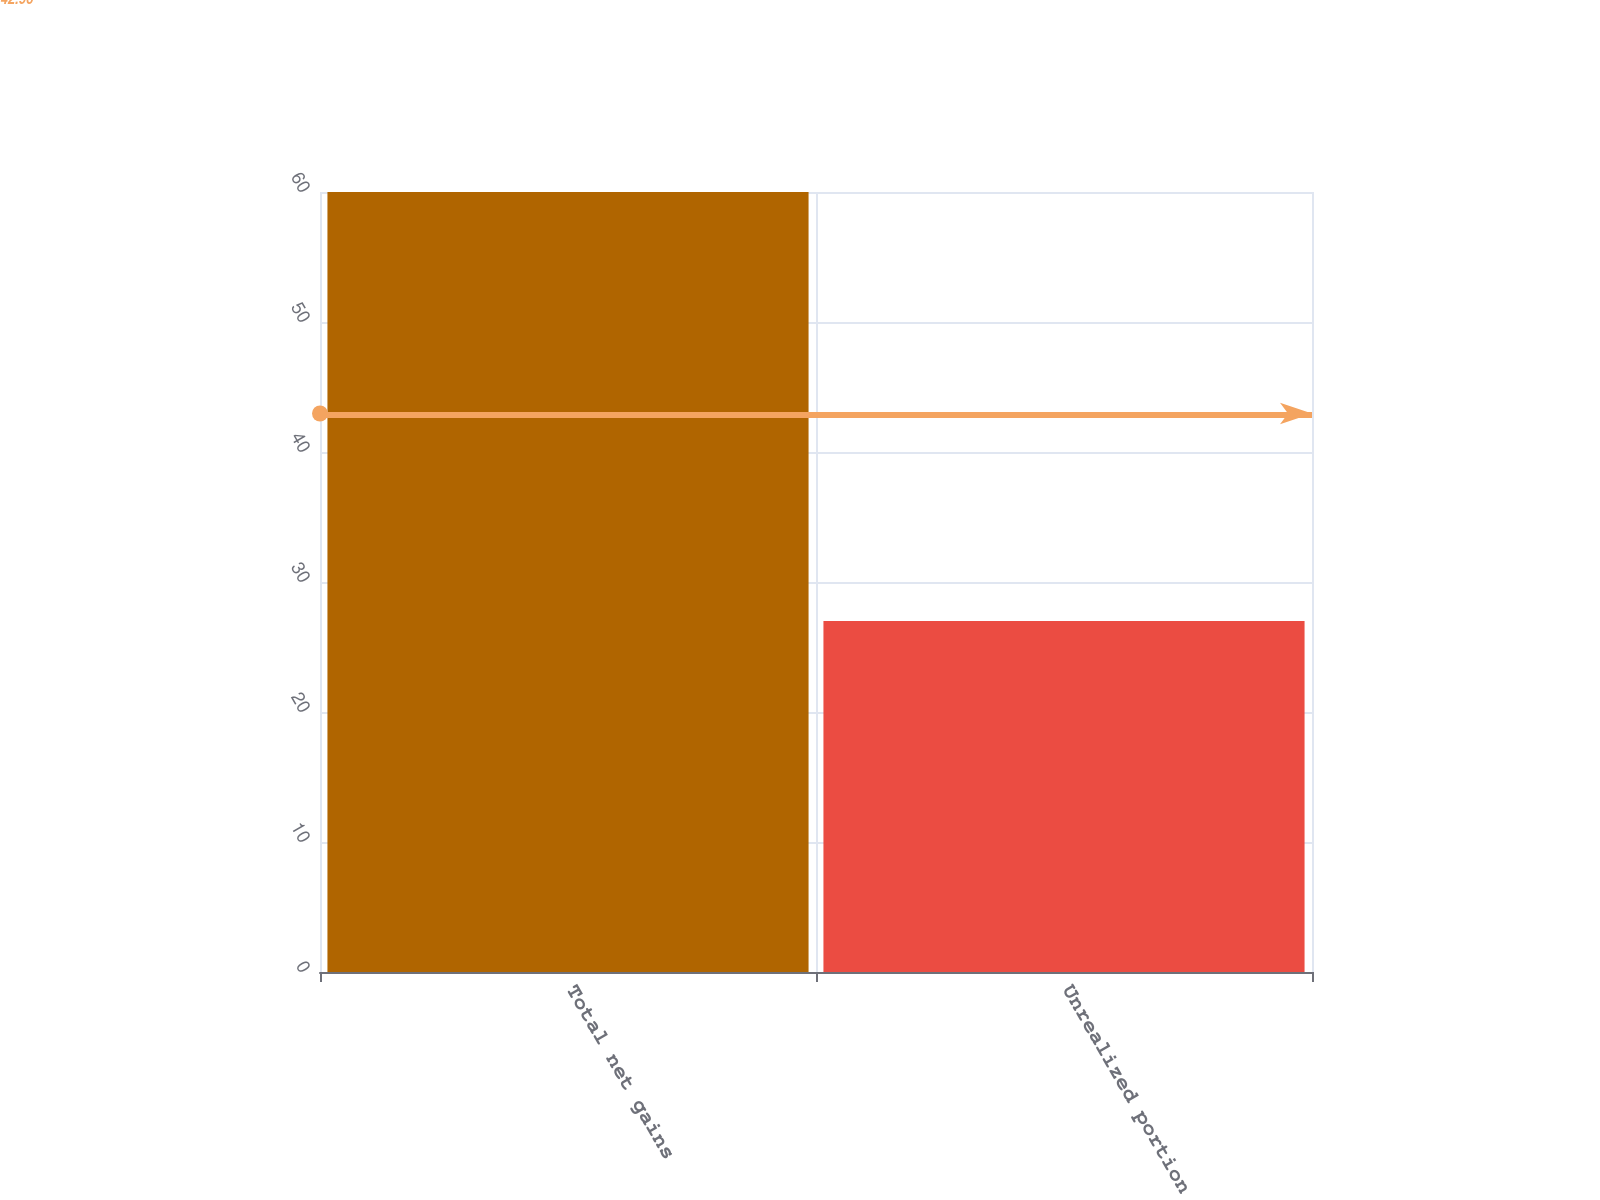Convert chart to OTSL. <chart><loc_0><loc_0><loc_500><loc_500><bar_chart><fcel>Total net gains<fcel>Unrealized portion<nl><fcel>60<fcel>27<nl></chart> 